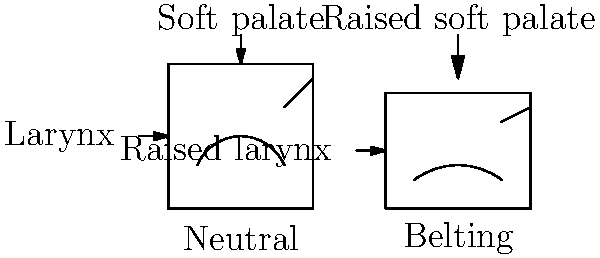In the diagrams above, which biomechanical differences between neutral singing and belting technique are most evident, and how do these differences contribute to the characteristic sound of belting? To answer this question, let's analyze the biomechanical differences between neutral singing and belting technique:

1. Larynx position:
   - In the neutral position, the larynx is lower.
   - In belting, the larynx is visibly raised.
   - Effect: A raised larynx shortens the vocal tract, resulting in brighter overtones and a more "forward" sound characteristic of belting.

2. Soft palate:
   - In the neutral position, the soft palate is relatively relaxed.
   - In belting, the soft palate is raised higher.
   - Effect: A raised soft palate increases the resonance space in the oral cavity, contributing to the powerful and projected sound of belting.

3. Tongue position:
   - In the neutral position, the tongue is relatively relaxed and low.
   - In belting, the tongue is slightly more elevated and forward.
   - Effect: This tongue position helps to shape the vocal tract for optimal resonance in belting, enhancing the "twang" quality often associated with this technique.

4. Overall vocal tract shape:
   - The belting technique shows a more constricted and shortened vocal tract compared to the neutral position.
   - Effect: This configuration allows for higher subglottal pressure and increased vocal fold closure, resulting in the louder, more forceful sound of belting.

The combination of these biomechanical differences contributes to the characteristic sound of belting by:
1. Increasing vocal intensity and projection
2. Enhancing higher overtones for a brighter timbre
3. Creating a more focused and "forward" placement of the voice
4. Allowing for sustained high notes with a speech-like quality

These adaptations enable singers to produce the powerful, cutting sound associated with belting while maintaining vocal efficiency and reducing strain.
Answer: Raised larynx, elevated soft palate, and more constricted vocal tract in belting, resulting in increased intensity, brighter timbre, and forward placement. 